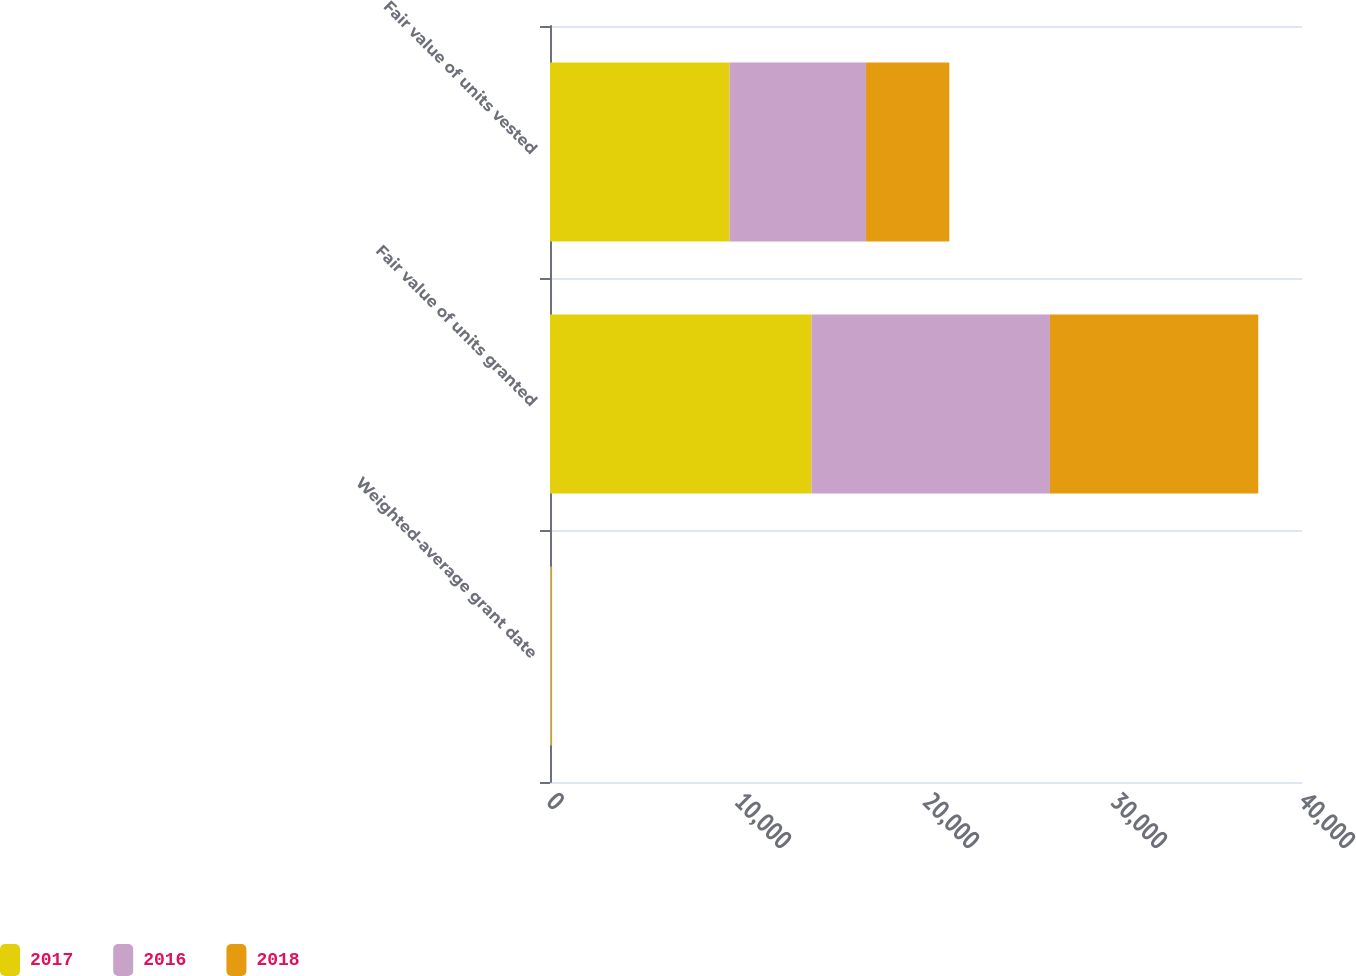Convert chart to OTSL. <chart><loc_0><loc_0><loc_500><loc_500><stacked_bar_chart><ecel><fcel>Weighted-average grant date<fcel>Fair value of units granted<fcel>Fair value of units vested<nl><fcel>2017<fcel>46.94<fcel>13907<fcel>9552<nl><fcel>2016<fcel>45.11<fcel>12685<fcel>7258<nl><fcel>2018<fcel>20.04<fcel>11081<fcel>4429<nl></chart> 